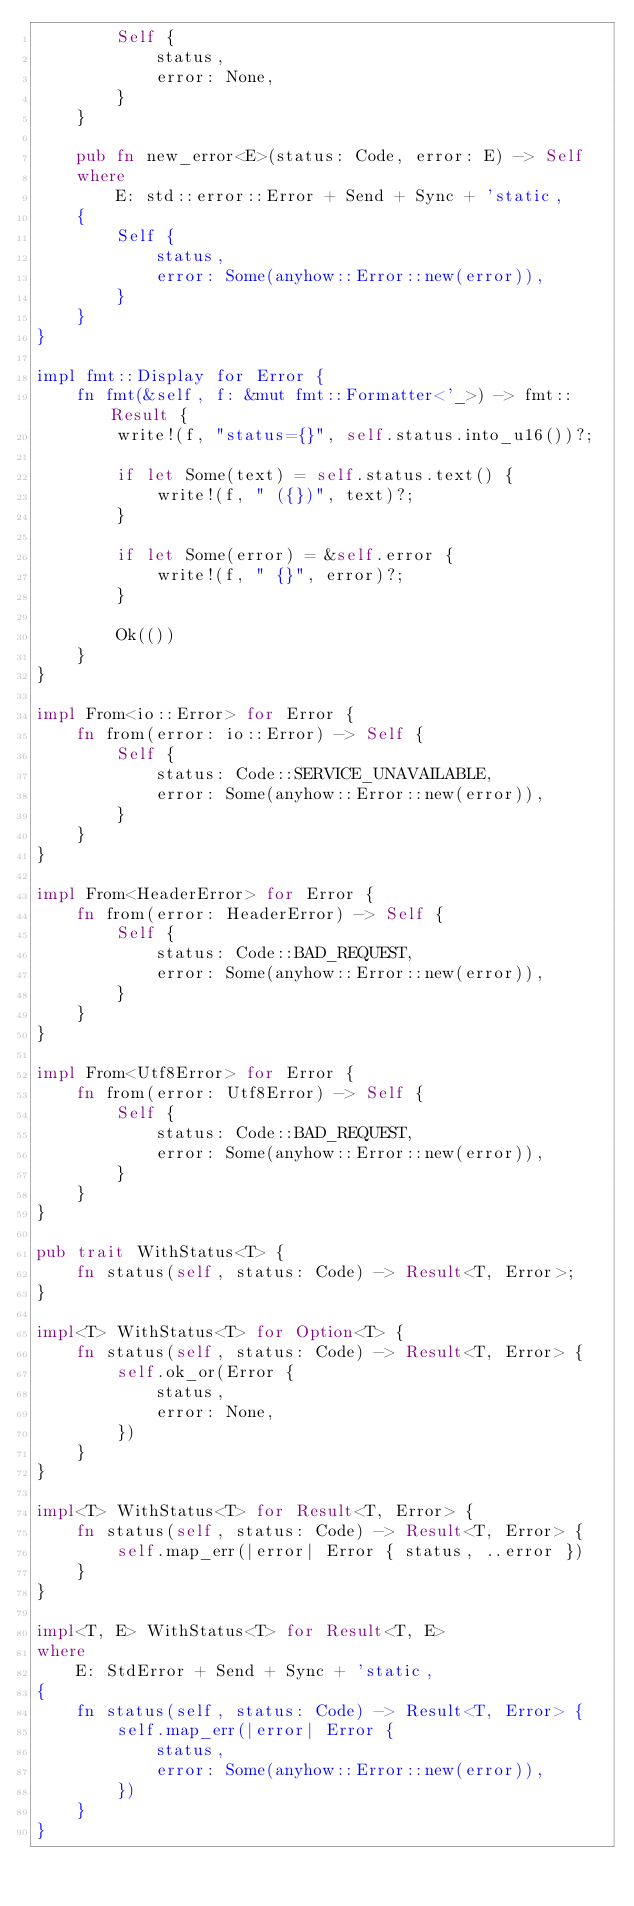<code> <loc_0><loc_0><loc_500><loc_500><_Rust_>        Self {
            status,
            error: None,
        }
    }

    pub fn new_error<E>(status: Code, error: E) -> Self
    where
        E: std::error::Error + Send + Sync + 'static,
    {
        Self {
            status,
            error: Some(anyhow::Error::new(error)),
        }
    }
}

impl fmt::Display for Error {
    fn fmt(&self, f: &mut fmt::Formatter<'_>) -> fmt::Result {
        write!(f, "status={}", self.status.into_u16())?;

        if let Some(text) = self.status.text() {
            write!(f, " ({})", text)?;
        }

        if let Some(error) = &self.error {
            write!(f, " {}", error)?;
        }

        Ok(())
    }
}

impl From<io::Error> for Error {
    fn from(error: io::Error) -> Self {
        Self {
            status: Code::SERVICE_UNAVAILABLE,
            error: Some(anyhow::Error::new(error)),
        }
    }
}

impl From<HeaderError> for Error {
    fn from(error: HeaderError) -> Self {
        Self {
            status: Code::BAD_REQUEST,
            error: Some(anyhow::Error::new(error)),
        }
    }
}

impl From<Utf8Error> for Error {
    fn from(error: Utf8Error) -> Self {
        Self {
            status: Code::BAD_REQUEST,
            error: Some(anyhow::Error::new(error)),
        }
    }
}

pub trait WithStatus<T> {
    fn status(self, status: Code) -> Result<T, Error>;
}

impl<T> WithStatus<T> for Option<T> {
    fn status(self, status: Code) -> Result<T, Error> {
        self.ok_or(Error {
            status,
            error: None,
        })
    }
}

impl<T> WithStatus<T> for Result<T, Error> {
    fn status(self, status: Code) -> Result<T, Error> {
        self.map_err(|error| Error { status, ..error })
    }
}

impl<T, E> WithStatus<T> for Result<T, E>
where
    E: StdError + Send + Sync + 'static,
{
    fn status(self, status: Code) -> Result<T, Error> {
        self.map_err(|error| Error {
            status,
            error: Some(anyhow::Error::new(error)),
        })
    }
}
</code> 